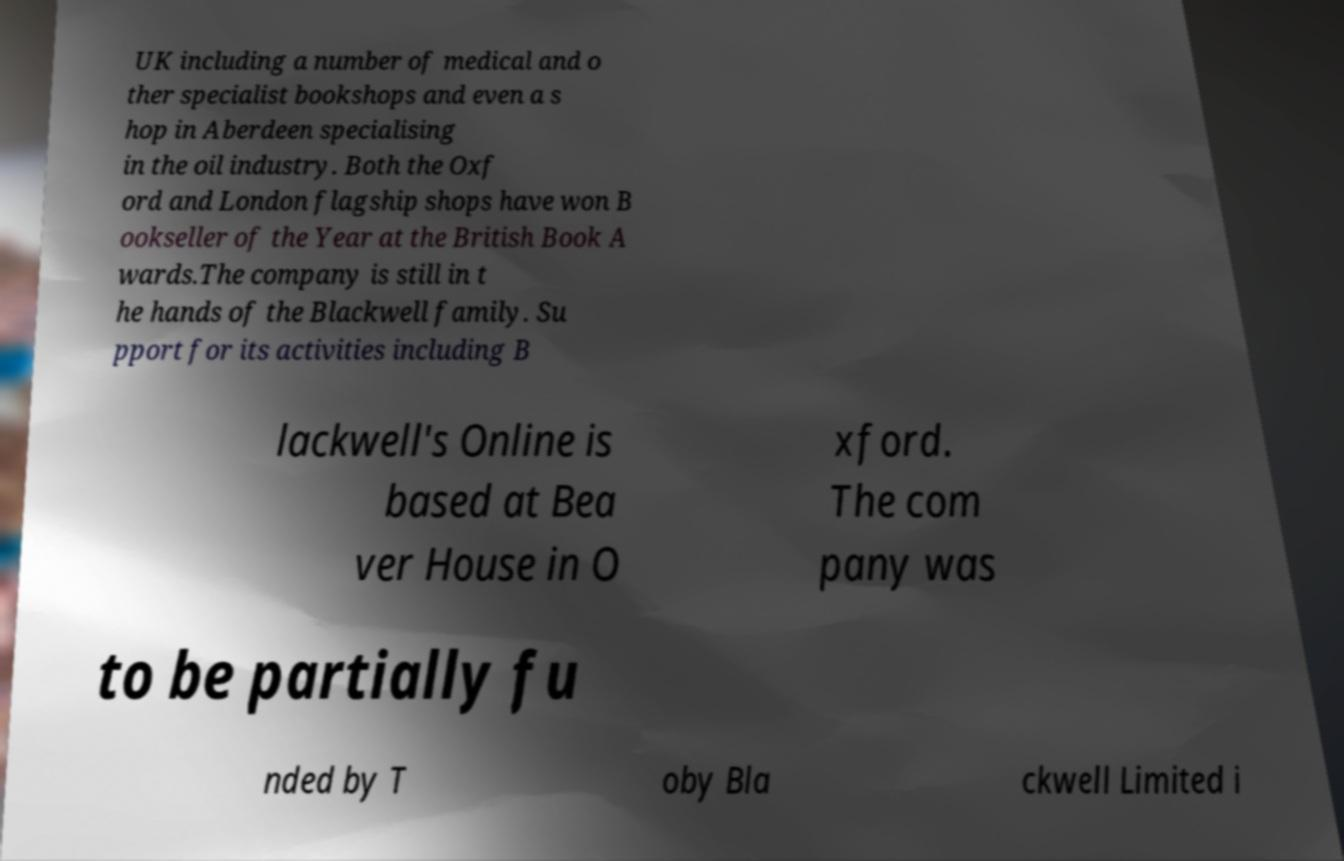Can you accurately transcribe the text from the provided image for me? UK including a number of medical and o ther specialist bookshops and even a s hop in Aberdeen specialising in the oil industry. Both the Oxf ord and London flagship shops have won B ookseller of the Year at the British Book A wards.The company is still in t he hands of the Blackwell family. Su pport for its activities including B lackwell's Online is based at Bea ver House in O xford. The com pany was to be partially fu nded by T oby Bla ckwell Limited i 